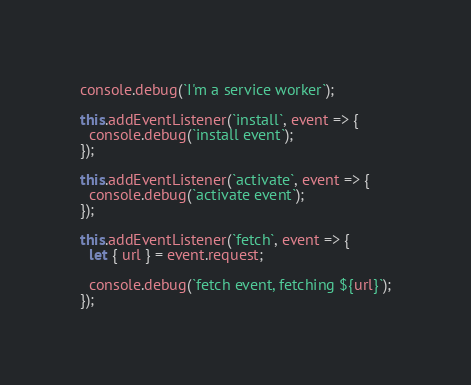<code> <loc_0><loc_0><loc_500><loc_500><_JavaScript_>console.debug(`I'm a service worker`);

this.addEventListener(`install`, event => {
  console.debug(`install event`);
});

this.addEventListener(`activate`, event => {
  console.debug(`activate event`);
});

this.addEventListener(`fetch`, event => {
  let { url } = event.request;

  console.debug(`fetch event, fetching ${url}`);
});
</code> 